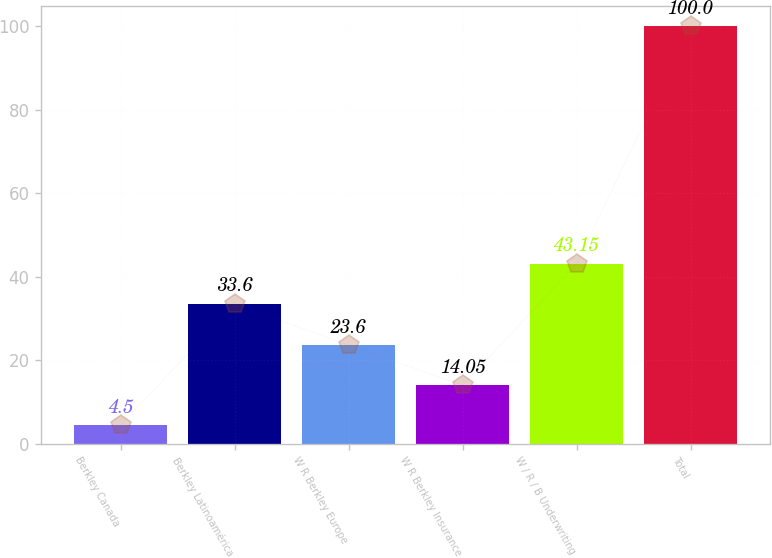<chart> <loc_0><loc_0><loc_500><loc_500><bar_chart><fcel>Berkley Canada<fcel>Berkley Latinoamérica<fcel>W R Berkley Europe<fcel>W R Berkley Insurance<fcel>W / R / B Underwriting<fcel>Total<nl><fcel>4.5<fcel>33.6<fcel>23.6<fcel>14.05<fcel>43.15<fcel>100<nl></chart> 